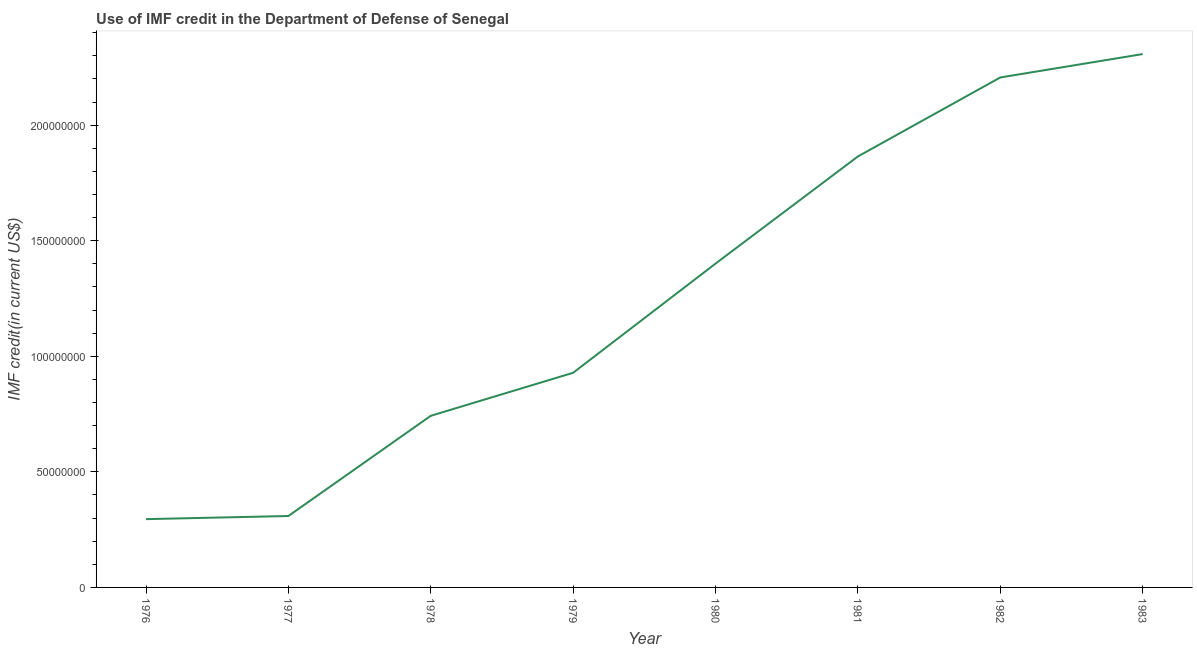What is the use of imf credit in dod in 1977?
Provide a short and direct response. 3.09e+07. Across all years, what is the maximum use of imf credit in dod?
Provide a succinct answer. 2.31e+08. Across all years, what is the minimum use of imf credit in dod?
Your response must be concise. 2.95e+07. In which year was the use of imf credit in dod minimum?
Provide a succinct answer. 1976. What is the sum of the use of imf credit in dod?
Provide a short and direct response. 1.01e+09. What is the difference between the use of imf credit in dod in 1976 and 1981?
Your answer should be compact. -1.57e+08. What is the average use of imf credit in dod per year?
Offer a very short reply. 1.26e+08. What is the median use of imf credit in dod?
Keep it short and to the point. 1.16e+08. Do a majority of the years between 1982 and 1981 (inclusive) have use of imf credit in dod greater than 100000000 US$?
Your response must be concise. No. What is the ratio of the use of imf credit in dod in 1976 to that in 1978?
Give a very brief answer. 0.4. What is the difference between the highest and the second highest use of imf credit in dod?
Your response must be concise. 1.01e+07. What is the difference between the highest and the lowest use of imf credit in dod?
Your answer should be very brief. 2.01e+08. In how many years, is the use of imf credit in dod greater than the average use of imf credit in dod taken over all years?
Provide a succinct answer. 4. Are the values on the major ticks of Y-axis written in scientific E-notation?
Your answer should be very brief. No. Does the graph contain any zero values?
Your answer should be compact. No. What is the title of the graph?
Ensure brevity in your answer.  Use of IMF credit in the Department of Defense of Senegal. What is the label or title of the Y-axis?
Your answer should be compact. IMF credit(in current US$). What is the IMF credit(in current US$) of 1976?
Keep it short and to the point. 2.95e+07. What is the IMF credit(in current US$) of 1977?
Make the answer very short. 3.09e+07. What is the IMF credit(in current US$) in 1978?
Ensure brevity in your answer.  7.43e+07. What is the IMF credit(in current US$) of 1979?
Keep it short and to the point. 9.29e+07. What is the IMF credit(in current US$) in 1980?
Give a very brief answer. 1.40e+08. What is the IMF credit(in current US$) in 1981?
Give a very brief answer. 1.86e+08. What is the IMF credit(in current US$) of 1982?
Offer a very short reply. 2.21e+08. What is the IMF credit(in current US$) in 1983?
Your answer should be very brief. 2.31e+08. What is the difference between the IMF credit(in current US$) in 1976 and 1977?
Offer a very short reply. -1.36e+06. What is the difference between the IMF credit(in current US$) in 1976 and 1978?
Give a very brief answer. -4.47e+07. What is the difference between the IMF credit(in current US$) in 1976 and 1979?
Ensure brevity in your answer.  -6.33e+07. What is the difference between the IMF credit(in current US$) in 1976 and 1980?
Provide a short and direct response. -1.11e+08. What is the difference between the IMF credit(in current US$) in 1976 and 1981?
Your answer should be very brief. -1.57e+08. What is the difference between the IMF credit(in current US$) in 1976 and 1982?
Your answer should be compact. -1.91e+08. What is the difference between the IMF credit(in current US$) in 1976 and 1983?
Your answer should be very brief. -2.01e+08. What is the difference between the IMF credit(in current US$) in 1977 and 1978?
Provide a succinct answer. -4.34e+07. What is the difference between the IMF credit(in current US$) in 1977 and 1979?
Keep it short and to the point. -6.20e+07. What is the difference between the IMF credit(in current US$) in 1977 and 1980?
Provide a succinct answer. -1.09e+08. What is the difference between the IMF credit(in current US$) in 1977 and 1981?
Ensure brevity in your answer.  -1.56e+08. What is the difference between the IMF credit(in current US$) in 1977 and 1982?
Keep it short and to the point. -1.90e+08. What is the difference between the IMF credit(in current US$) in 1977 and 1983?
Offer a very short reply. -2.00e+08. What is the difference between the IMF credit(in current US$) in 1978 and 1979?
Offer a terse response. -1.86e+07. What is the difference between the IMF credit(in current US$) in 1978 and 1980?
Provide a short and direct response. -6.59e+07. What is the difference between the IMF credit(in current US$) in 1978 and 1981?
Your answer should be compact. -1.12e+08. What is the difference between the IMF credit(in current US$) in 1978 and 1982?
Your answer should be very brief. -1.46e+08. What is the difference between the IMF credit(in current US$) in 1978 and 1983?
Offer a terse response. -1.57e+08. What is the difference between the IMF credit(in current US$) in 1979 and 1980?
Keep it short and to the point. -4.72e+07. What is the difference between the IMF credit(in current US$) in 1979 and 1981?
Offer a terse response. -9.36e+07. What is the difference between the IMF credit(in current US$) in 1979 and 1982?
Provide a succinct answer. -1.28e+08. What is the difference between the IMF credit(in current US$) in 1979 and 1983?
Offer a terse response. -1.38e+08. What is the difference between the IMF credit(in current US$) in 1980 and 1981?
Offer a terse response. -4.64e+07. What is the difference between the IMF credit(in current US$) in 1980 and 1982?
Offer a terse response. -8.05e+07. What is the difference between the IMF credit(in current US$) in 1980 and 1983?
Offer a terse response. -9.07e+07. What is the difference between the IMF credit(in current US$) in 1981 and 1982?
Your answer should be compact. -3.42e+07. What is the difference between the IMF credit(in current US$) in 1981 and 1983?
Offer a very short reply. -4.43e+07. What is the difference between the IMF credit(in current US$) in 1982 and 1983?
Your response must be concise. -1.01e+07. What is the ratio of the IMF credit(in current US$) in 1976 to that in 1977?
Make the answer very short. 0.96. What is the ratio of the IMF credit(in current US$) in 1976 to that in 1978?
Your answer should be compact. 0.4. What is the ratio of the IMF credit(in current US$) in 1976 to that in 1979?
Your response must be concise. 0.32. What is the ratio of the IMF credit(in current US$) in 1976 to that in 1980?
Give a very brief answer. 0.21. What is the ratio of the IMF credit(in current US$) in 1976 to that in 1981?
Keep it short and to the point. 0.16. What is the ratio of the IMF credit(in current US$) in 1976 to that in 1982?
Provide a short and direct response. 0.13. What is the ratio of the IMF credit(in current US$) in 1976 to that in 1983?
Offer a very short reply. 0.13. What is the ratio of the IMF credit(in current US$) in 1977 to that in 1978?
Your response must be concise. 0.42. What is the ratio of the IMF credit(in current US$) in 1977 to that in 1979?
Your answer should be very brief. 0.33. What is the ratio of the IMF credit(in current US$) in 1977 to that in 1980?
Your answer should be compact. 0.22. What is the ratio of the IMF credit(in current US$) in 1977 to that in 1981?
Your response must be concise. 0.17. What is the ratio of the IMF credit(in current US$) in 1977 to that in 1982?
Offer a terse response. 0.14. What is the ratio of the IMF credit(in current US$) in 1977 to that in 1983?
Give a very brief answer. 0.13. What is the ratio of the IMF credit(in current US$) in 1978 to that in 1980?
Your response must be concise. 0.53. What is the ratio of the IMF credit(in current US$) in 1978 to that in 1981?
Offer a very short reply. 0.4. What is the ratio of the IMF credit(in current US$) in 1978 to that in 1982?
Offer a terse response. 0.34. What is the ratio of the IMF credit(in current US$) in 1978 to that in 1983?
Offer a terse response. 0.32. What is the ratio of the IMF credit(in current US$) in 1979 to that in 1980?
Make the answer very short. 0.66. What is the ratio of the IMF credit(in current US$) in 1979 to that in 1981?
Ensure brevity in your answer.  0.5. What is the ratio of the IMF credit(in current US$) in 1979 to that in 1982?
Keep it short and to the point. 0.42. What is the ratio of the IMF credit(in current US$) in 1979 to that in 1983?
Offer a very short reply. 0.4. What is the ratio of the IMF credit(in current US$) in 1980 to that in 1981?
Keep it short and to the point. 0.75. What is the ratio of the IMF credit(in current US$) in 1980 to that in 1982?
Offer a very short reply. 0.64. What is the ratio of the IMF credit(in current US$) in 1980 to that in 1983?
Offer a terse response. 0.61. What is the ratio of the IMF credit(in current US$) in 1981 to that in 1982?
Provide a succinct answer. 0.84. What is the ratio of the IMF credit(in current US$) in 1981 to that in 1983?
Provide a succinct answer. 0.81. What is the ratio of the IMF credit(in current US$) in 1982 to that in 1983?
Offer a terse response. 0.96. 